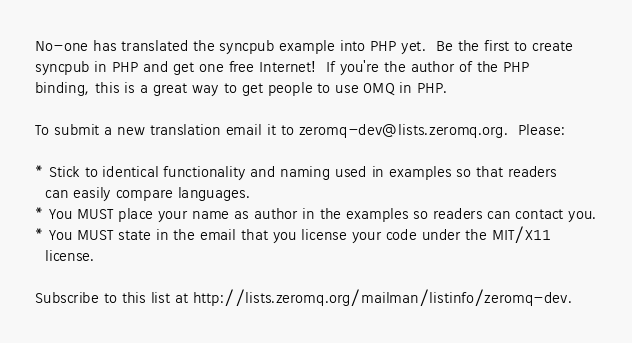<code> <loc_0><loc_0><loc_500><loc_500><_PHP_>No-one has translated the syncpub example into PHP yet.  Be the first to create
syncpub in PHP and get one free Internet!  If you're the author of the PHP
binding, this is a great way to get people to use 0MQ in PHP.

To submit a new translation email it to zeromq-dev@lists.zeromq.org.  Please:

* Stick to identical functionality and naming used in examples so that readers
  can easily compare languages.
* You MUST place your name as author in the examples so readers can contact you.
* You MUST state in the email that you license your code under the MIT/X11
  license.

Subscribe to this list at http://lists.zeromq.org/mailman/listinfo/zeromq-dev.
</code> 